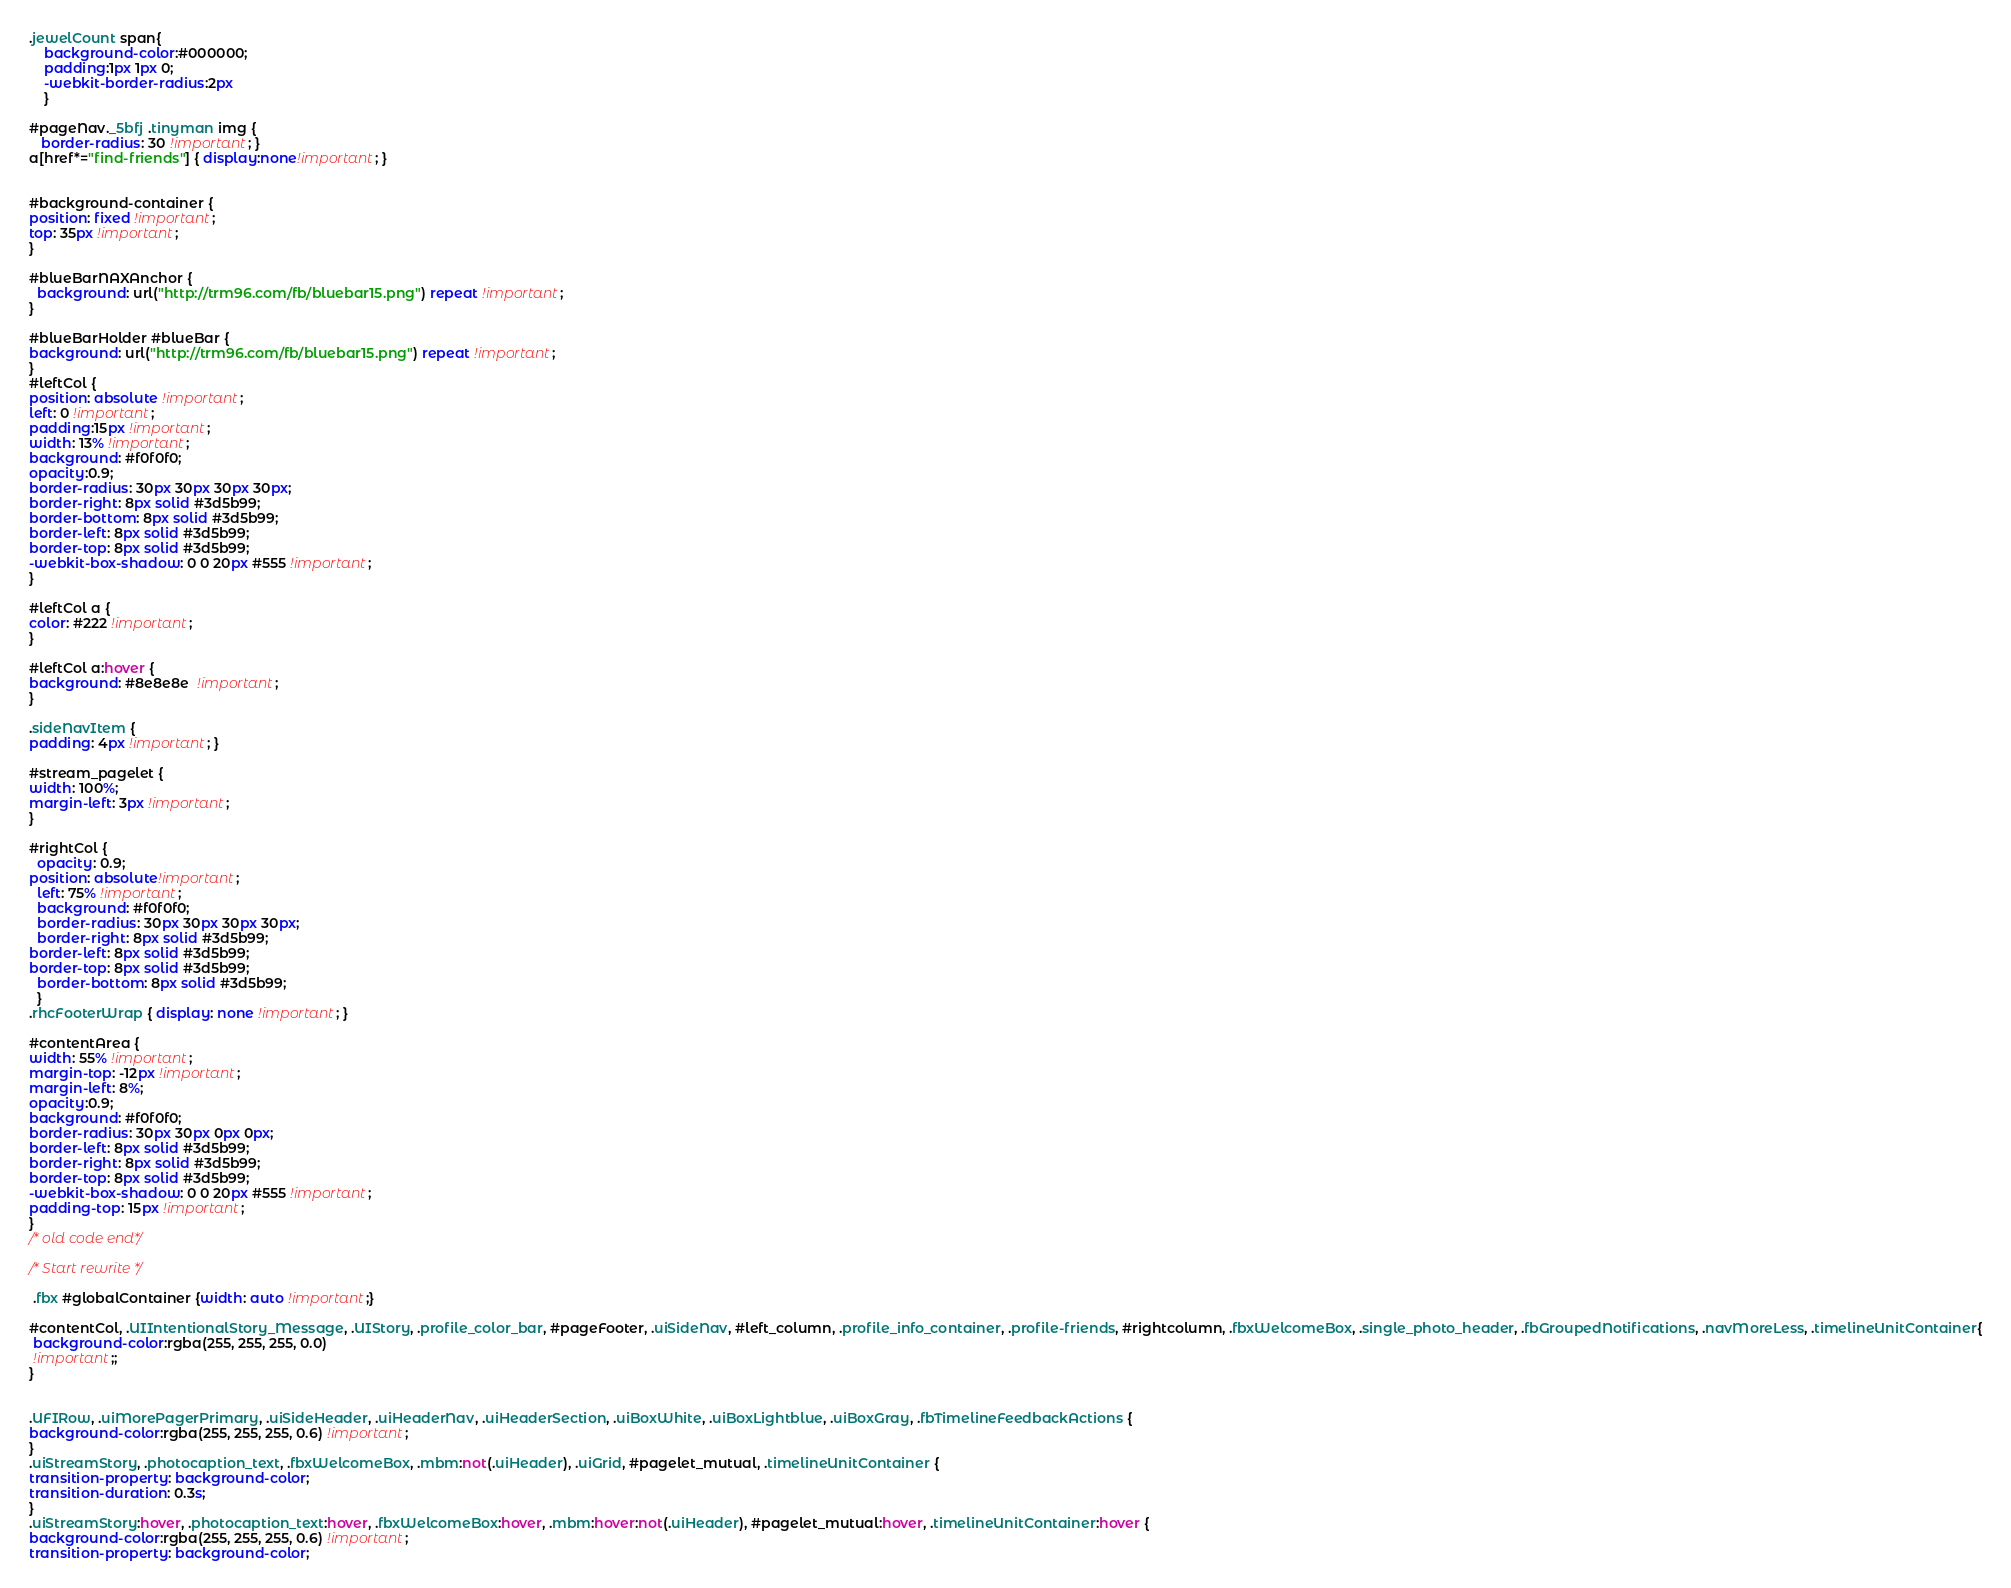<code> <loc_0><loc_0><loc_500><loc_500><_CSS_>
.jewelCount span{
	background-color:#000000;
	padding:1px 1px 0;
	-webkit-border-radius:2px
	}

#pageNav._5bfj .tinyman img {
   border-radius: 30 !important; }
a[href*="find-friends"] { display:none!important; }


#background-container { 
position: fixed !important; 
top: 35px !important; 
}

#blueBarNAXAnchor {
  background: url("http://trm96.com/fb/bluebar15.png") repeat !important;
}

#blueBarHolder #blueBar { 
background: url("http://trm96.com/fb/bluebar15.png") repeat !important;
}
#leftCol { 
position: absolute !important;   
left: 0 !important;
padding:15px !important; 
width: 13% !important; 
background: #f0f0f0;
opacity:0.9;
border-radius: 30px 30px 30px 30px;  
border-right: 8px solid #3d5b99;
border-bottom: 8px solid #3d5b99;
border-left: 8px solid #3d5b99;
border-top: 8px solid #3d5b99;
-webkit-box-shadow: 0 0 20px #555 !important; 
}

#leftCol a { 
color: #222 !important; 
}

#leftCol a:hover { 
background: #8e8e8e  !important; 
}

.sideNavItem { 
padding: 4px !important; }

#stream_pagelet {
width: 100%; 
margin-left: 3px !important;
}

#rightCol {
  opacity: 0.9;
position: absolute!important;
  left: 75% !important;
  background: #f0f0f0;
  border-radius: 30px 30px 30px 30px;
  border-right: 8px solid #3d5b99; 
border-left: 8px solid #3d5b99;
border-top: 8px solid #3d5b99;
  border-bottom: 8px solid #3d5b99;
  }
.rhcFooterWrap { display: none !important; }

#contentArea { 
width: 55% !important;
margin-top: -12px !important;
margin-left: 8%;
opacity:0.9;
background: #f0f0f0;
border-radius: 30px 30px 0px 0px;
border-left: 8px solid #3d5b99;
border-right: 8px solid #3d5b99; 
border-top: 8px solid #3d5b99; 
-webkit-box-shadow: 0 0 20px #555 !important;
padding-top: 15px !important; 
} 
/* old code end*/

/* Start rewrite */

 .fbx #globalContainer {width: auto !important;}

#contentCol, .UIIntentionalStory_Message, .UIStory, .profile_color_bar, #pageFooter, .uiSideNav, #left_column, .profile_info_container, .profile-friends, #rightcolumn, .fbxWelcomeBox, .single_photo_header, .fbGroupedNotifications, .navMoreLess, .timelineUnitContainer{
 background-color:rgba(255, 255, 255, 0.0)
 !important;;
}


.UFIRow, .uiMorePagerPrimary, .uiSideHeader, .uiHeaderNav, .uiHeaderSection, .uiBoxWhite, .uiBoxLightblue, .uiBoxGray, .fbTimelineFeedbackActions {
background-color:rgba(255, 255, 255, 0.6) !important;
}
.uiStreamStory, .photocaption_text, .fbxWelcomeBox, .mbm:not(.uiHeader), .uiGrid, #pagelet_mutual, .timelineUnitContainer {
transition-property: background-color;
transition-duration: 0.3s;
}
.uiStreamStory:hover, .photocaption_text:hover, .fbxWelcomeBox:hover, .mbm:hover:not(.uiHeader), #pagelet_mutual:hover, .timelineUnitContainer:hover {
background-color:rgba(255, 255, 255, 0.6) !important;
transition-property: background-color;</code> 